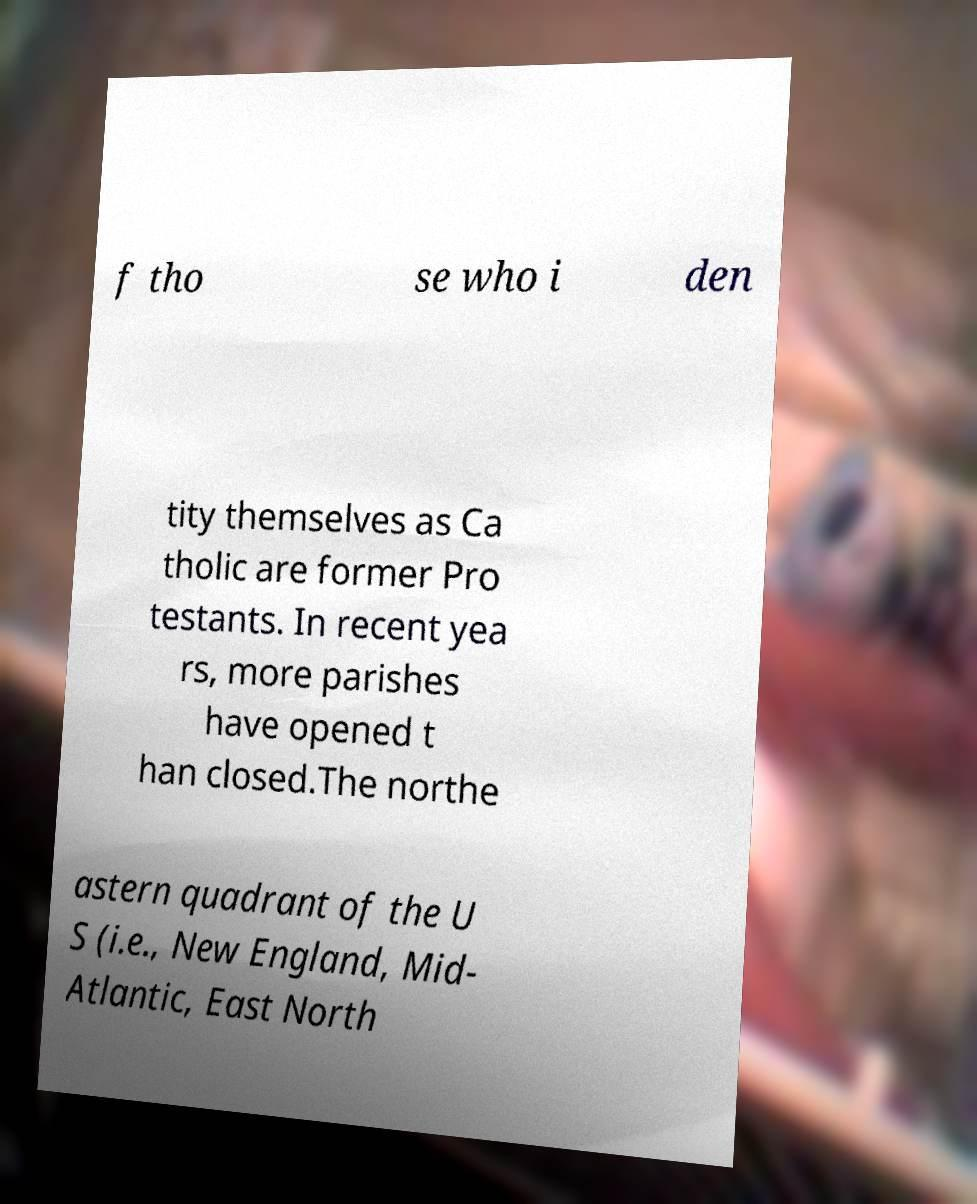Could you assist in decoding the text presented in this image and type it out clearly? f tho se who i den tity themselves as Ca tholic are former Pro testants. In recent yea rs, more parishes have opened t han closed.The northe astern quadrant of the U S (i.e., New England, Mid- Atlantic, East North 